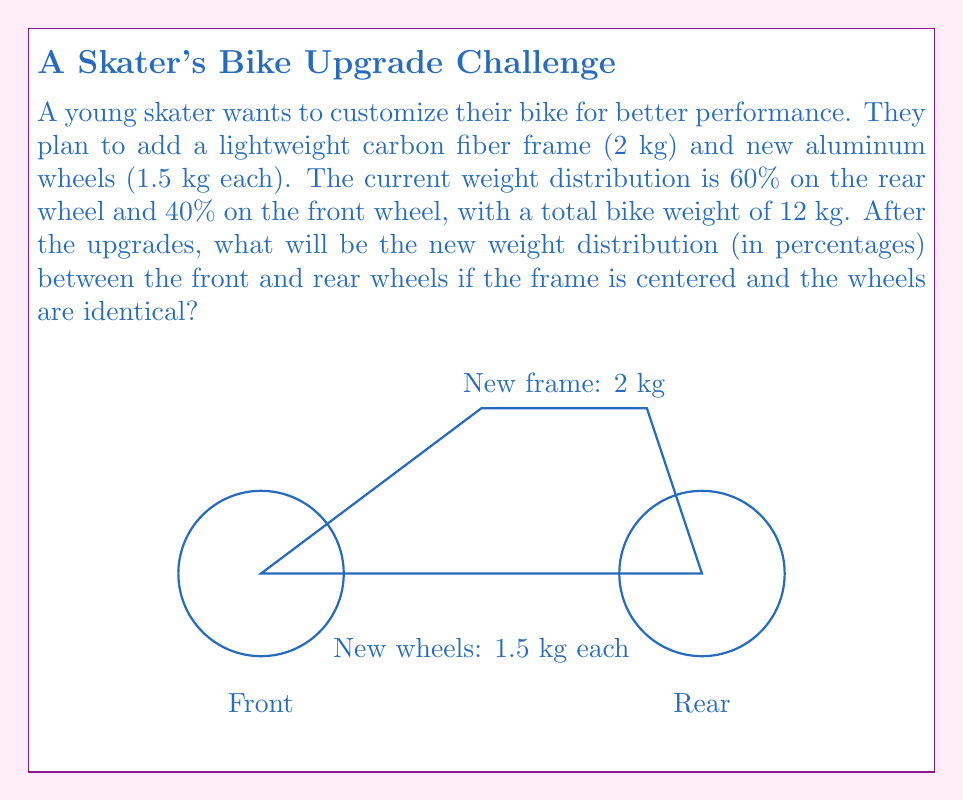Give your solution to this math problem. Let's solve this step-by-step:

1) First, calculate the new total weight of the bike:
   $$12 \text{ kg} - \text{old frame and wheels} + 2 \text{ kg} + 2(1.5 \text{ kg}) = 12 + 2 + 3 = 17 \text{ kg}$$

2) The current weight distribution:
   Front: $0.4 \times 12 = 4.8 \text{ kg}$
   Rear: $0.6 \times 12 = 7.2 \text{ kg}$

3) The new frame (2 kg) is centered, so it adds 1 kg to both front and rear.
   Each new wheel adds 1.5 kg to its respective side.

4) New weight distribution:
   Front: $4.8 + 1 + 1.5 = 7.3 \text{ kg}$
   Rear: $7.2 + 1 + 1.5 = 9.7 \text{ kg}$

5) Calculate the new percentages:
   Front: $\frac{7.3}{17} \times 100\% \approx 42.94\%$
   Rear: $\frac{9.7}{17} \times 100\% \approx 57.06\%$

Therefore, the new weight distribution is approximately 42.94% on the front wheel and 57.06% on the rear wheel.
Answer: 42.94% front, 57.06% rear 